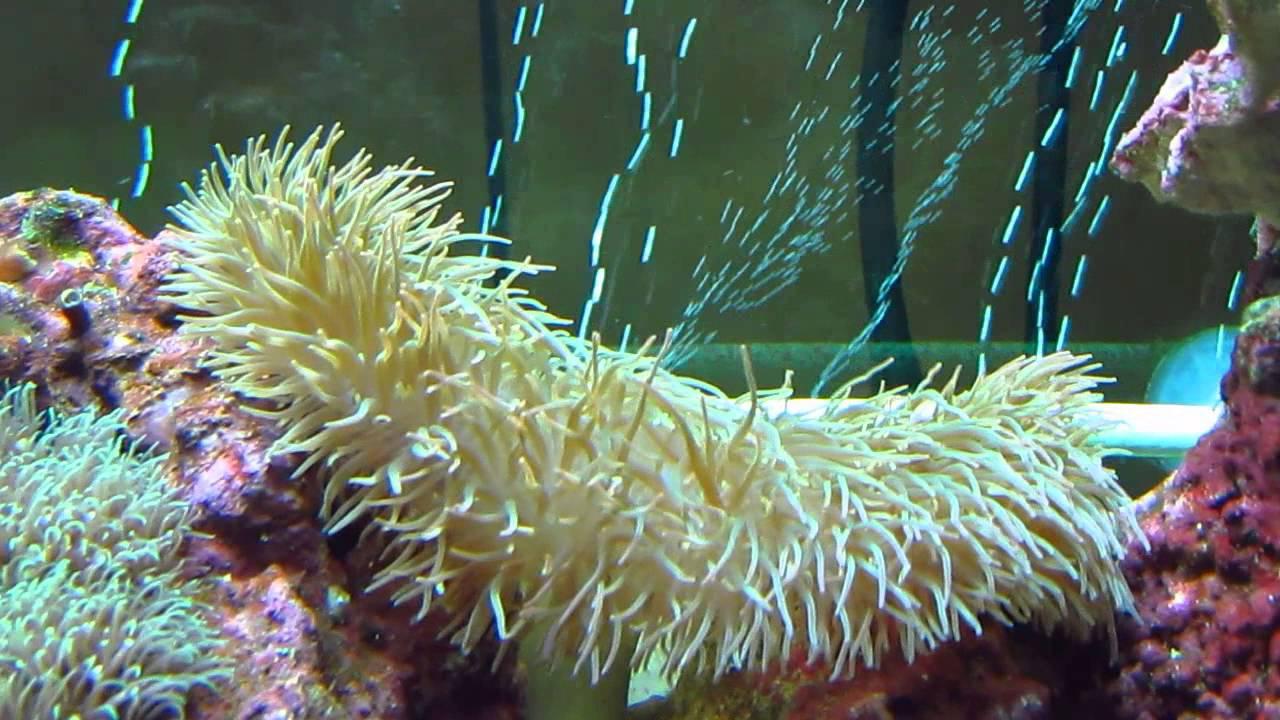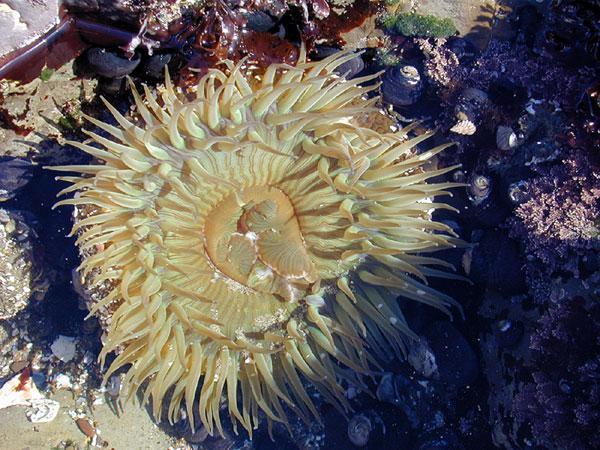The first image is the image on the left, the second image is the image on the right. For the images shown, is this caption "An image features an anemone with pale tendrils and a rosy-orange body." true? Answer yes or no. No. 